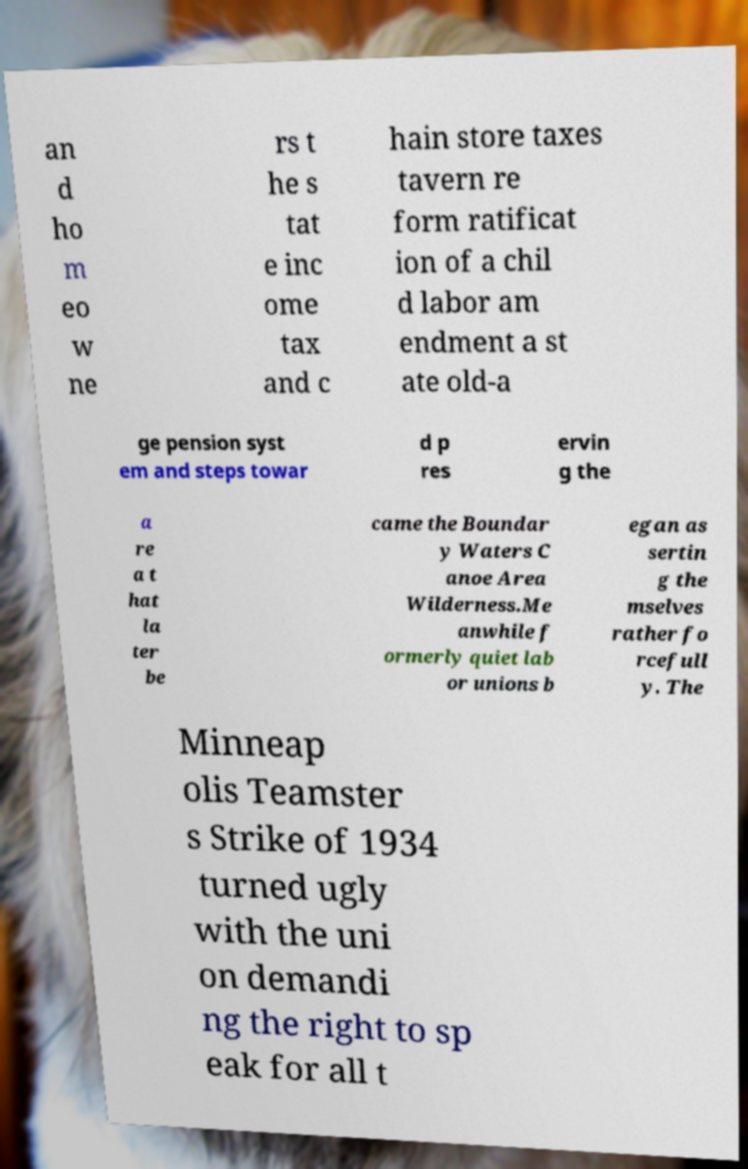What messages or text are displayed in this image? I need them in a readable, typed format. an d ho m eo w ne rs t he s tat e inc ome tax and c hain store taxes tavern re form ratificat ion of a chil d labor am endment a st ate old-a ge pension syst em and steps towar d p res ervin g the a re a t hat la ter be came the Boundar y Waters C anoe Area Wilderness.Me anwhile f ormerly quiet lab or unions b egan as sertin g the mselves rather fo rcefull y. The Minneap olis Teamster s Strike of 1934 turned ugly with the uni on demandi ng the right to sp eak for all t 